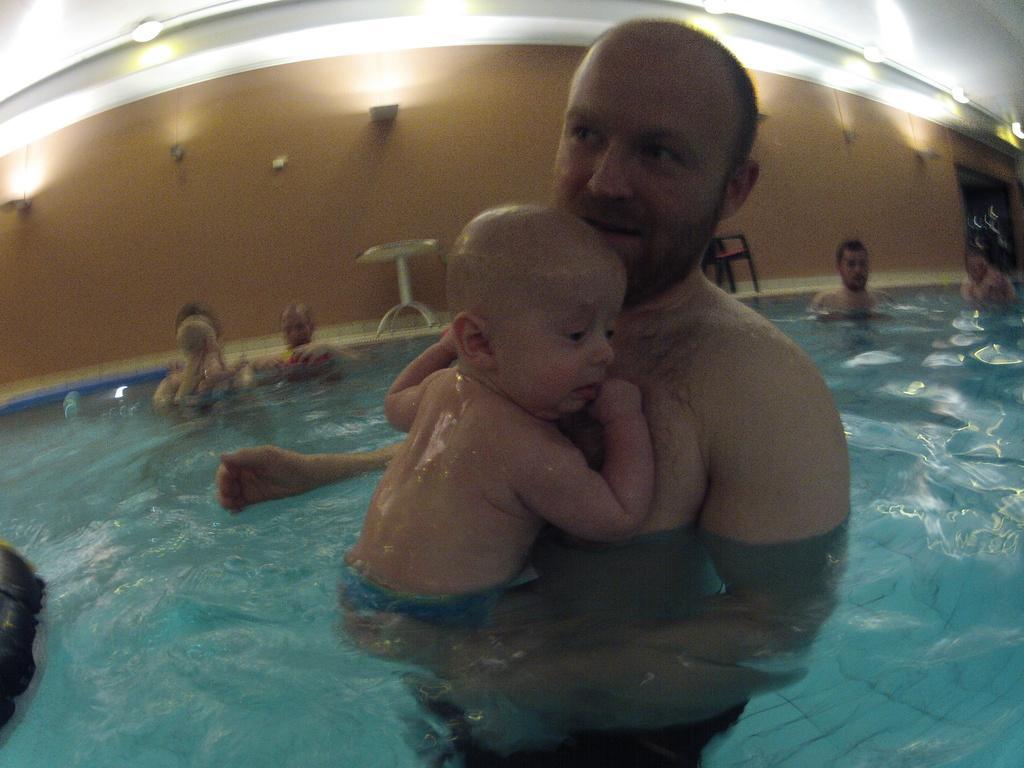Describe this image in one or two sentences. In the center of the image there is a person and a baby in the swimming pool. In the background we can see persons, water, table, chair, doors, lights and wall. 